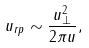Convert formula to latex. <formula><loc_0><loc_0><loc_500><loc_500>u _ { r p } \sim \frac { u _ { \perp } ^ { 2 } } { 2 \pi u } ,</formula> 